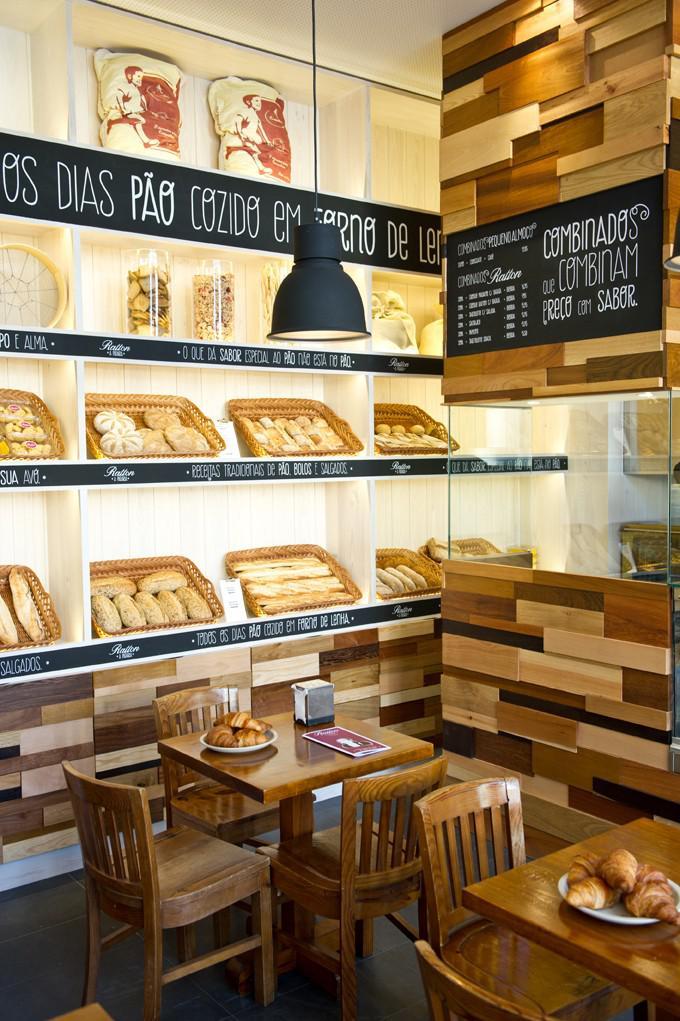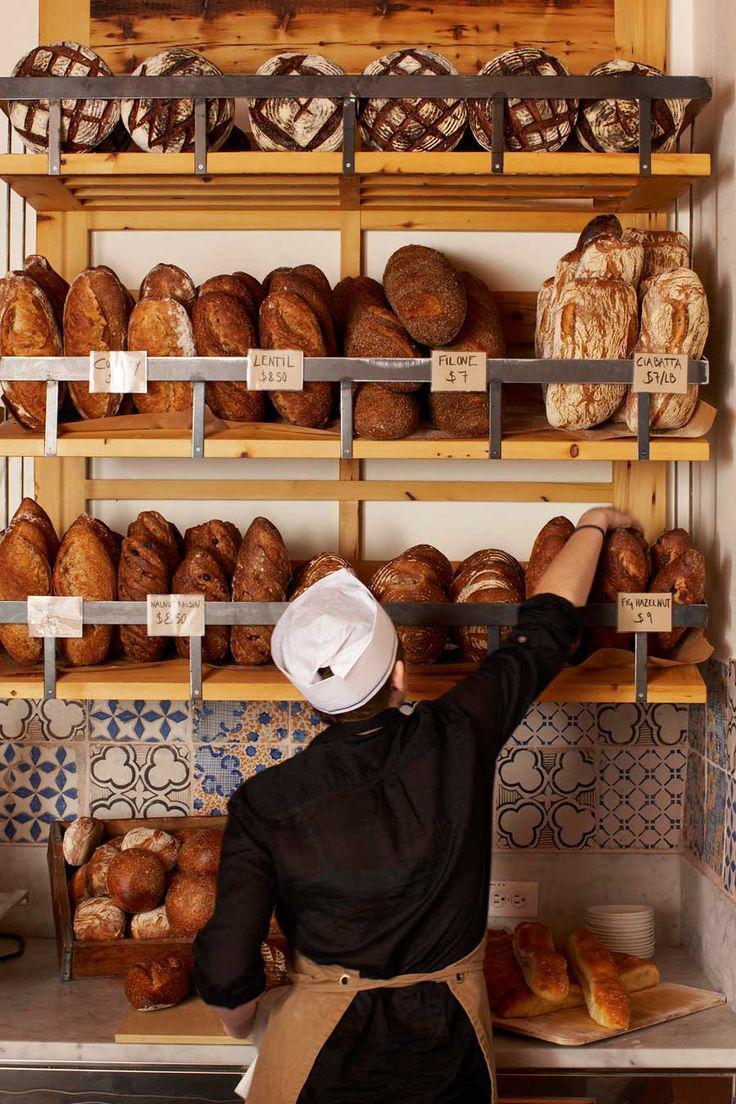The first image is the image on the left, the second image is the image on the right. Evaluate the accuracy of this statement regarding the images: "At least one bakery worker is shown in at least one image.". Is it true? Answer yes or no. Yes. The first image is the image on the left, the second image is the image on the right. Given the left and right images, does the statement "An image includes a bakery worker wearing a hat." hold true? Answer yes or no. Yes. 